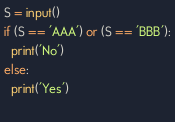<code> <loc_0><loc_0><loc_500><loc_500><_Python_>S = input()
if (S == 'AAA') or (S == 'BBB'):
  print('No')
else:
  print('Yes')
  
</code> 